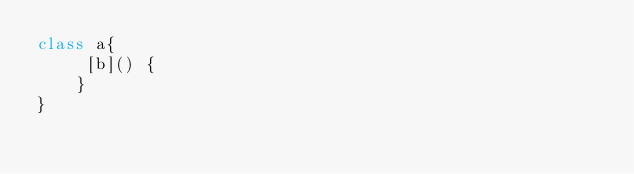<code> <loc_0><loc_0><loc_500><loc_500><_JavaScript_>class a{
     [b]() {
    }
}
</code> 